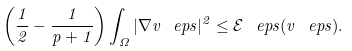<formula> <loc_0><loc_0><loc_500><loc_500>\left ( \frac { 1 } { 2 } - \frac { 1 } { p + 1 } \right ) \int _ { \Omega } | \nabla v ^ { \ } e p s | ^ { 2 } \leq \mathcal { E } ^ { \ } e p s ( v ^ { \ } e p s ) .</formula> 